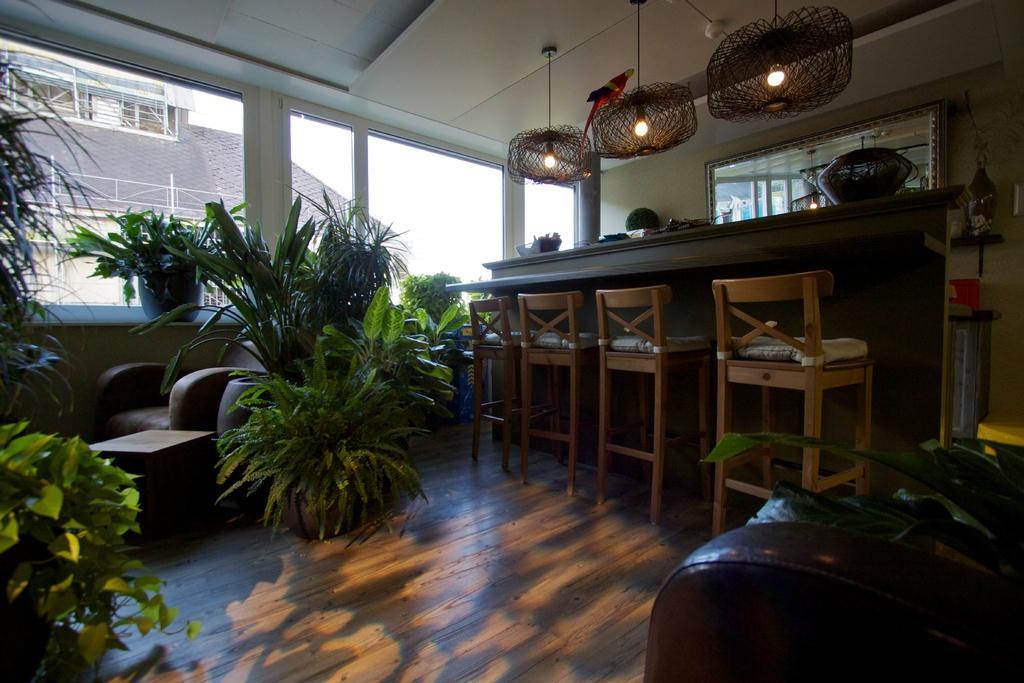Can you describe this image briefly? In a room there is a table. On the table there are some baskets and pots. There are four chairs. And to the corner there is a sofa. There are many plants. On the top there are many lights. There is a window. Outside the window there is a building. 